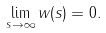Convert formula to latex. <formula><loc_0><loc_0><loc_500><loc_500>\lim _ { s \to \infty } w ( s ) = 0 .</formula> 